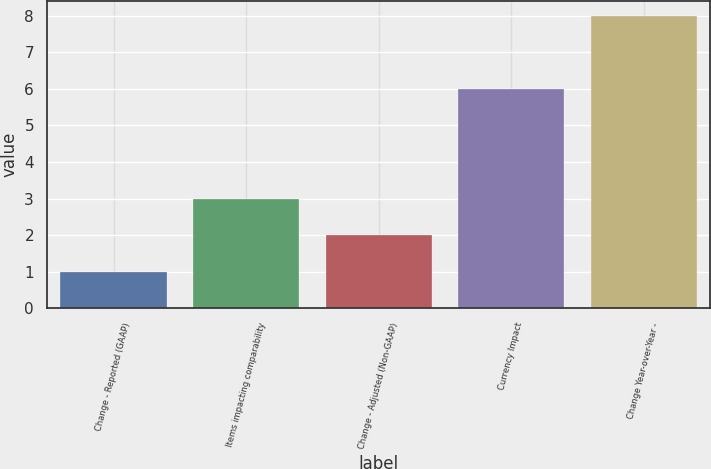Convert chart to OTSL. <chart><loc_0><loc_0><loc_500><loc_500><bar_chart><fcel>Change - Reported (GAAP)<fcel>Items impacting comparability<fcel>Change - Adjusted (Non-GAAP)<fcel>Currency Impact<fcel>Change Year-over-Year -<nl><fcel>1<fcel>3<fcel>2<fcel>6<fcel>8<nl></chart> 